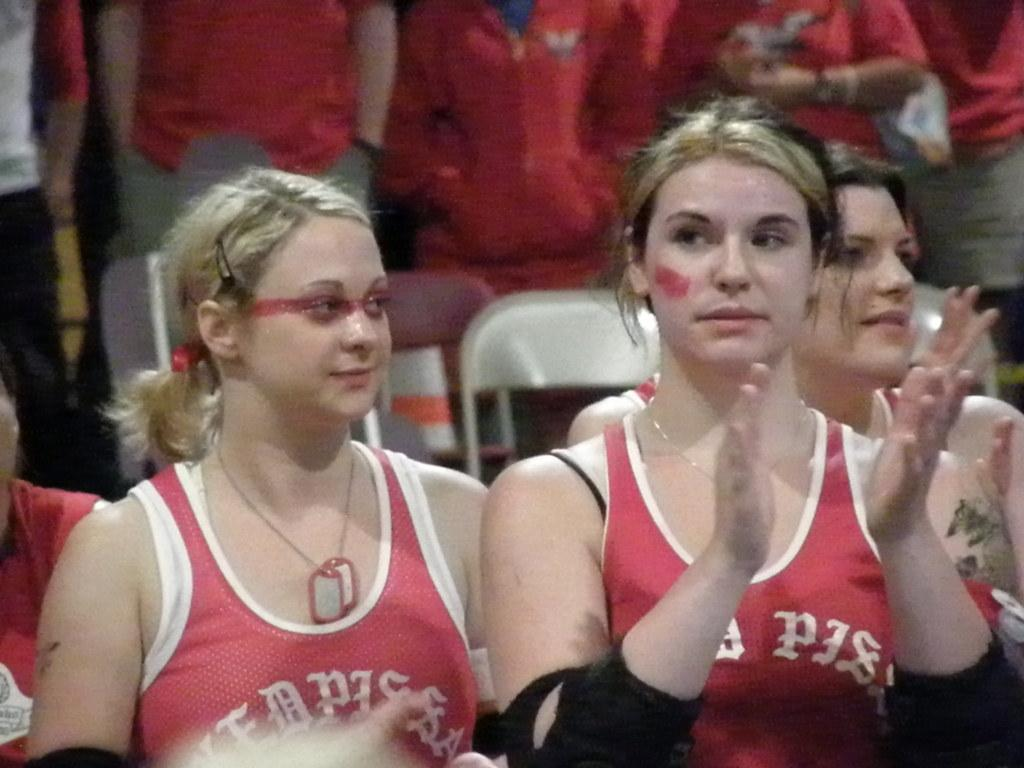Who is present in the image? There are women in the image. What are the women wearing? The women are wearing red dresses. What can be seen in the background of the image? There are chairs and people standing in the background of the image. Can you see a crown on any of the women's heads in the image? No, there is no crown visible on any of the women's heads in the image. 